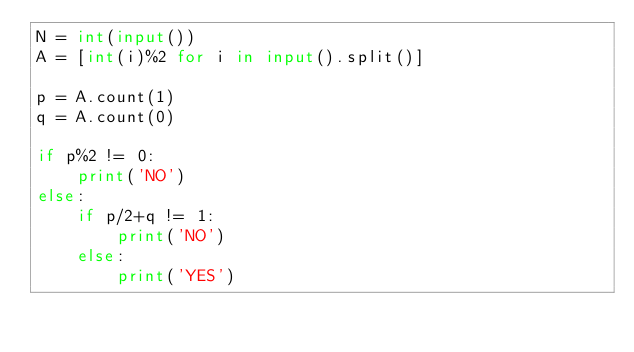Convert code to text. <code><loc_0><loc_0><loc_500><loc_500><_Python_>N = int(input())
A = [int(i)%2 for i in input().split()]

p = A.count(1)
q = A.count(0)

if p%2 != 0:
    print('NO')
else:
    if p/2+q != 1:
        print('NO')
    else:
        print('YES')
</code> 